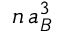<formula> <loc_0><loc_0><loc_500><loc_500>n \, a _ { B } ^ { 3 }</formula> 